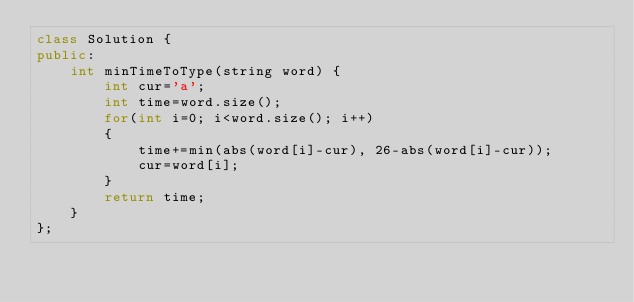Convert code to text. <code><loc_0><loc_0><loc_500><loc_500><_C++_>class Solution {
public:
    int minTimeToType(string word) {
        int cur='a';
        int time=word.size();
        for(int i=0; i<word.size(); i++)
        {
            time+=min(abs(word[i]-cur), 26-abs(word[i]-cur));
            cur=word[i];
        }
        return time;
    }
};</code> 